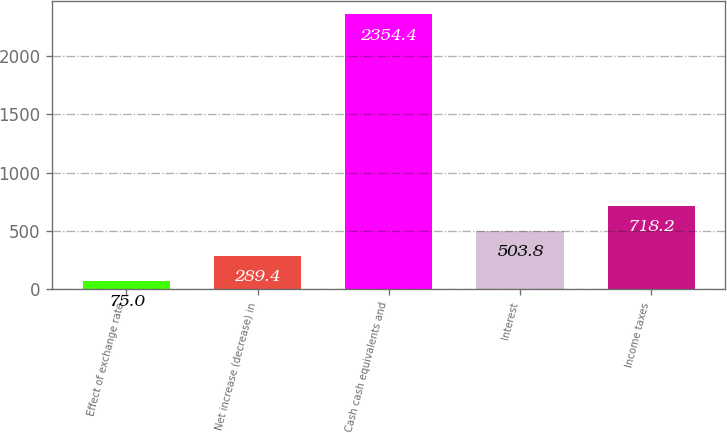Convert chart. <chart><loc_0><loc_0><loc_500><loc_500><bar_chart><fcel>Effect of exchange rate<fcel>Net increase (decrease) in<fcel>Cash cash equivalents and<fcel>Interest<fcel>Income taxes<nl><fcel>75<fcel>289.4<fcel>2354.4<fcel>503.8<fcel>718.2<nl></chart> 